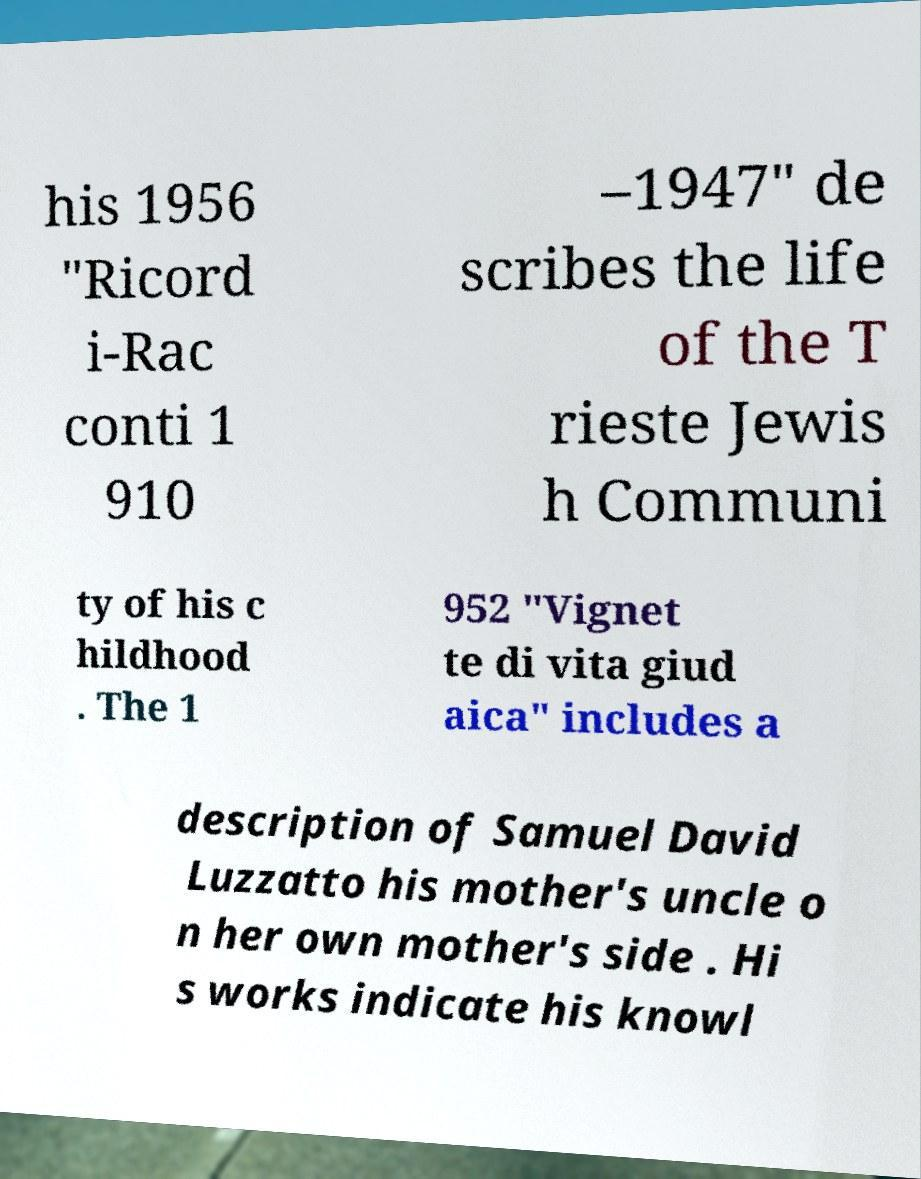I need the written content from this picture converted into text. Can you do that? his 1956 "Ricord i-Rac conti 1 910 –1947" de scribes the life of the T rieste Jewis h Communi ty of his c hildhood . The 1 952 "Vignet te di vita giud aica" includes a description of Samuel David Luzzatto his mother's uncle o n her own mother's side . Hi s works indicate his knowl 